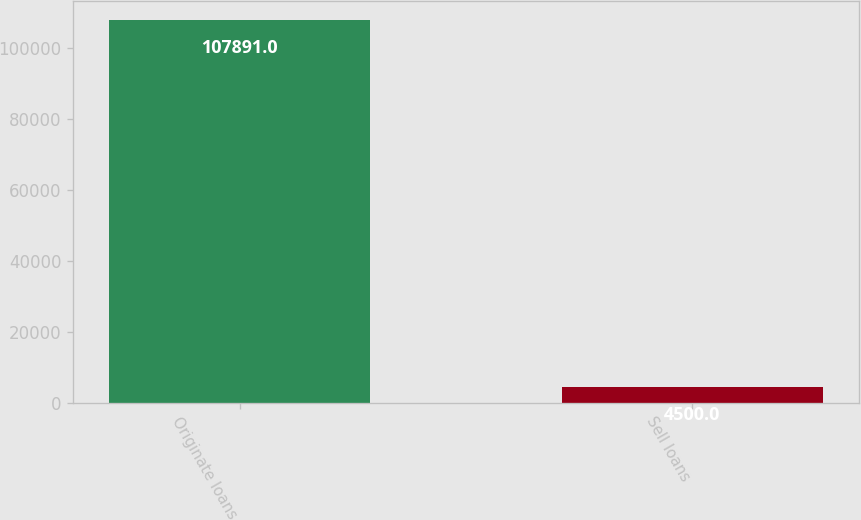<chart> <loc_0><loc_0><loc_500><loc_500><bar_chart><fcel>Originate loans<fcel>Sell loans<nl><fcel>107891<fcel>4500<nl></chart> 